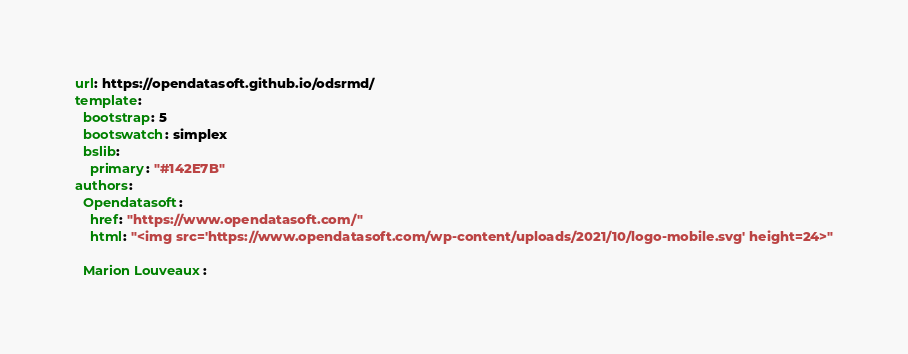Convert code to text. <code><loc_0><loc_0><loc_500><loc_500><_YAML_>url: https://opendatasoft.github.io/odsrmd/
template:
  bootstrap: 5
  bootswatch: simplex
  bslib:
    primary: "#142E7B"
authors:
  Opendatasoft:
    href: "https://www.opendatasoft.com/"
    html: "<img src='https://www.opendatasoft.com/wp-content/uploads/2021/10/logo-mobile.svg' height=24>"

  Marion Louveaux:
</code> 